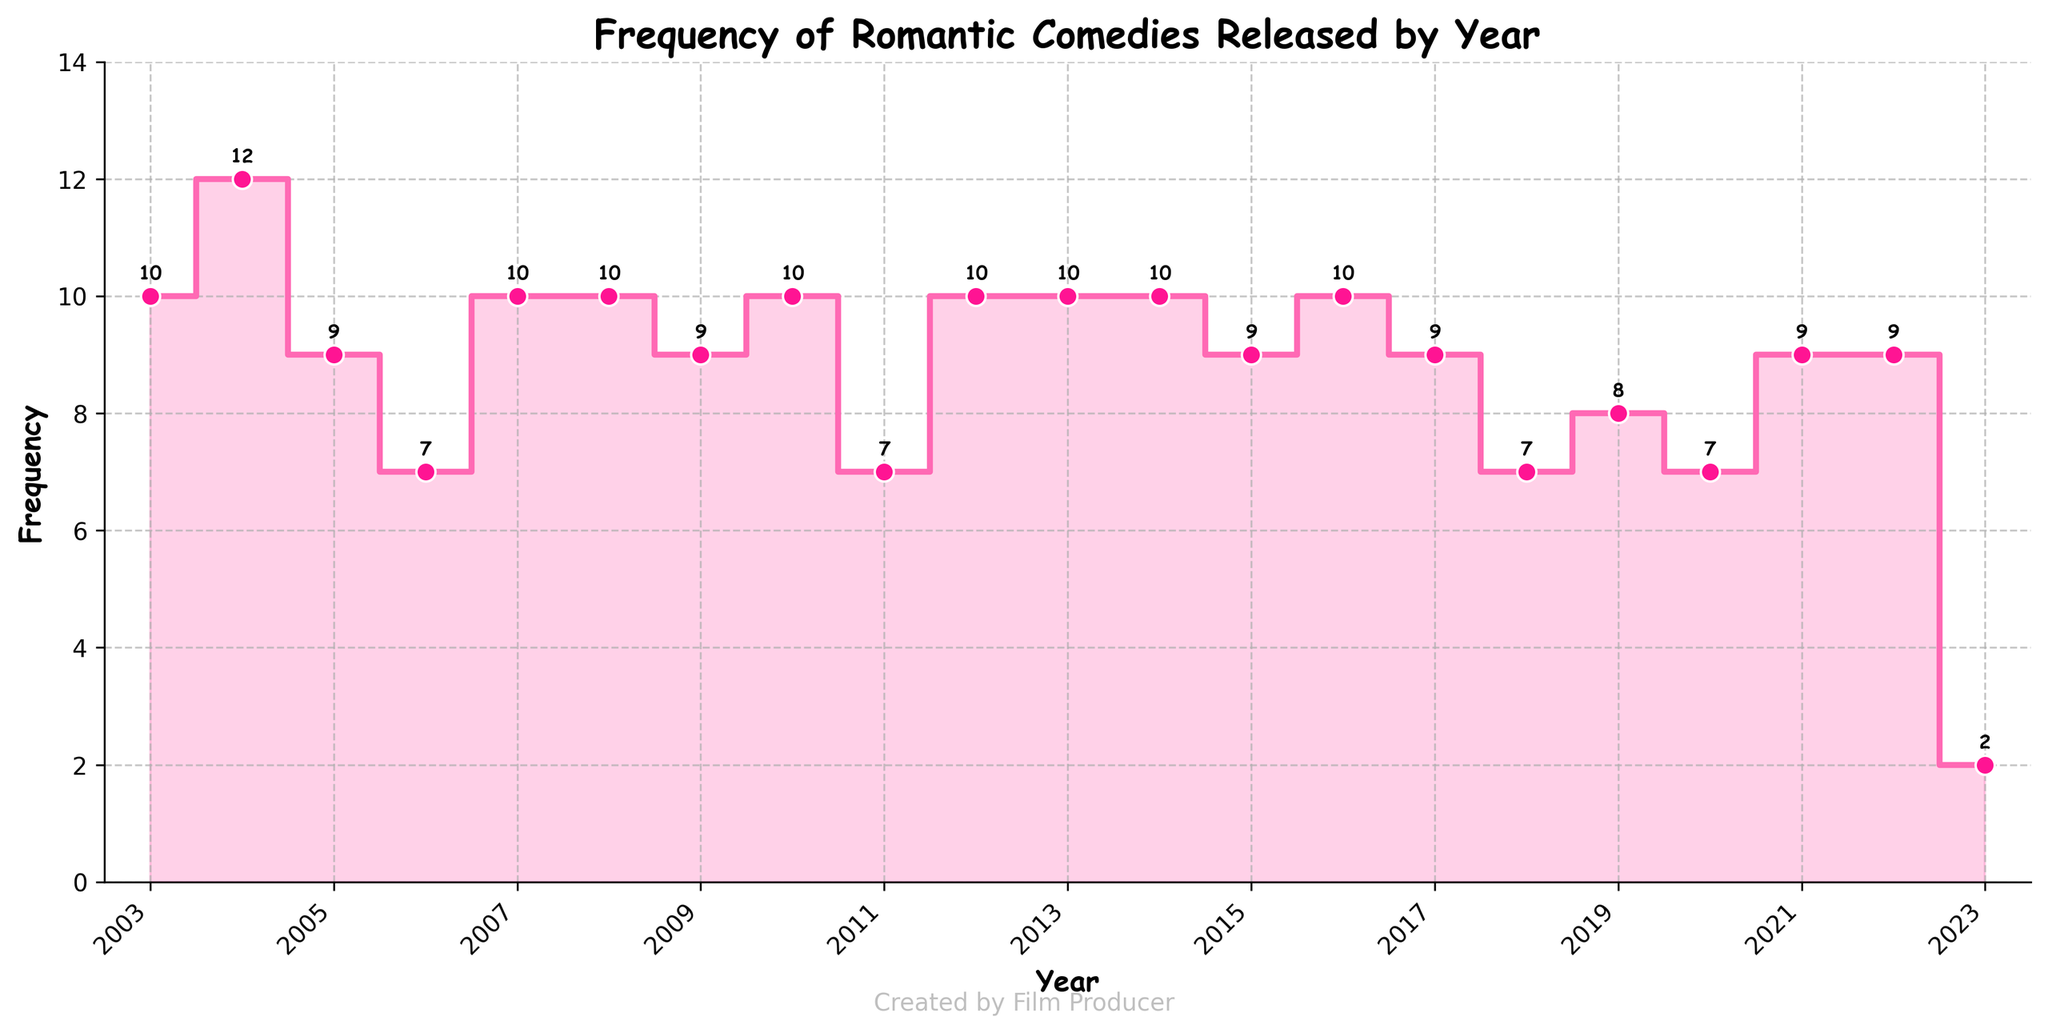What is the title of the figure? The title of the figure is usually at the top and is often written in a bold or larger font to easily identify the subject of the plot.
Answer: Frequency of Romantic Comedies Released by Year What are the labels on the x-axis and y-axis? The labels on the axes are typically placed beside the respective axis and describe what the axis represents.
Answer: The x-axis is labeled 'Year' and the y-axis is labeled 'Frequency' How many data points are shown in the figure? To determine the number of data points, count the number of unique years or markers on the plot. Each year has a corresponding frequency.
Answer: 21 Which year had the highest frequency of romantic comedy releases? Find the highest point on the y-axis and trace it to the corresponding year on the x-axis. The plot uses filled markers to indicate data points.
Answer: 2003 How did the frequency of romantic comedy releases change between the years 2003 and 2004? Check the frequencies for the years 2003 and 2004 and calculate the difference. Compare the markers on the stair plot for these years.
Answer: The frequency decreased from 10 to 12 In which year did the frequency of romantic comedy releases first drop below 5? Start from the left (earliest year) and move rightwards until the frequency drops below 5. This can be seen where the plot steps down.
Answer: 2007 What was the frequency of romantic comedy releases in 2010? Find the year 2010 on the x-axis, then check the corresponding y-axis value or the annotation.
Answer: 10 Between which consecutive years did the largest single increase in frequency occur? Look for the steepest upward step between two consecutive years in the stair plot and compare the changes.
Answer: 2018 to 2021 What is the average frequency of romantic comedy releases over the period shown? Sum all the frequencies and divide by the number of years. Summing the shown values and dividing by 21 yields the average.
Answer: (3+2+4+1+3+3+2+4+2+3+3+2...+2)/21 = ~2.5 Did the frequency of releases trend upwards, downwards, or remain stable over the years? Analyze the general direction of the stair plot from left to right. If the steps mostly go up, it's an upwards trend; if they go down, a downwards trend; if they stay mostly flat, it's stable.
Answer: Downwards 